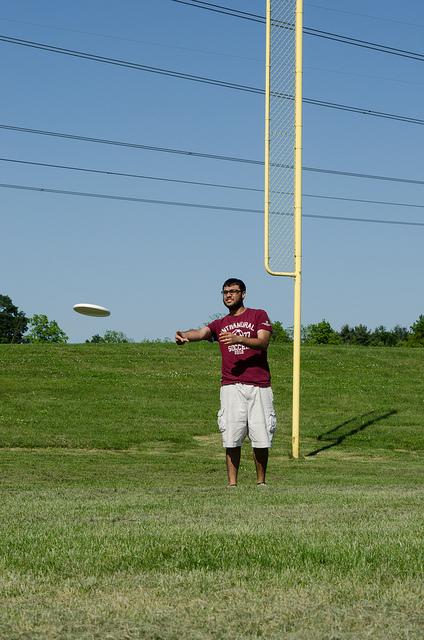What is flying towards the person?
Concise answer only. Frisbee. Is the grass healthy?
Answer briefly. Yes. What color is the man's shirt?
Answer briefly. Red. 